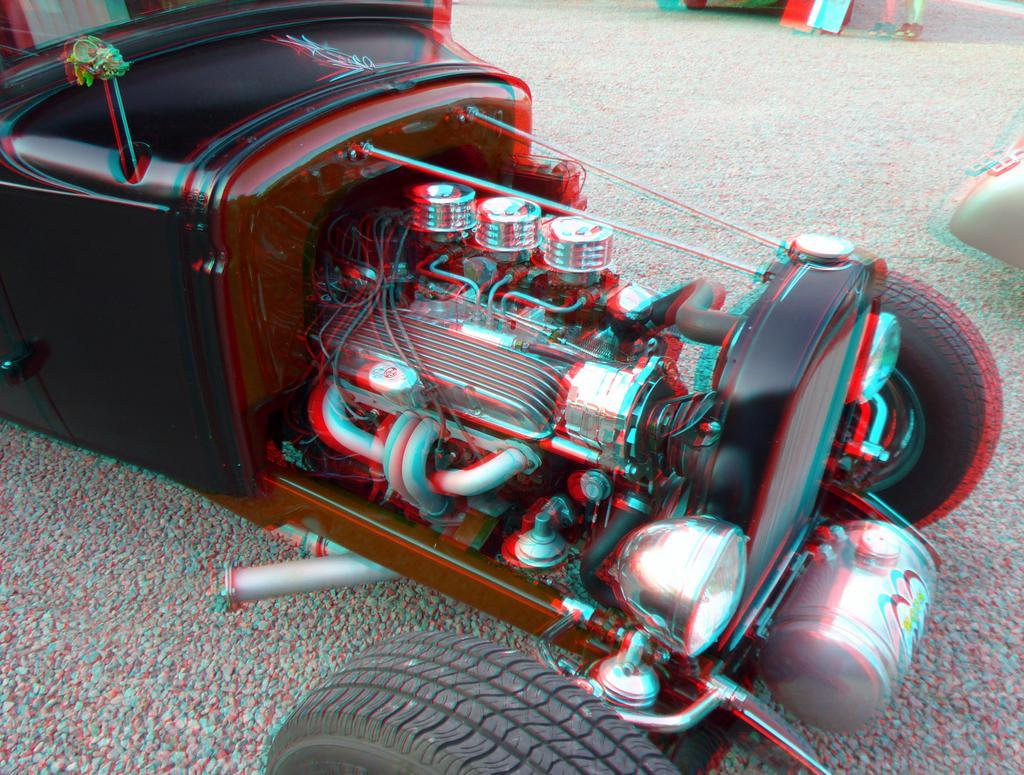Please provide a concise description of this image. In this picture we can see a vehicle on the ground and in the background we can see some objects. 